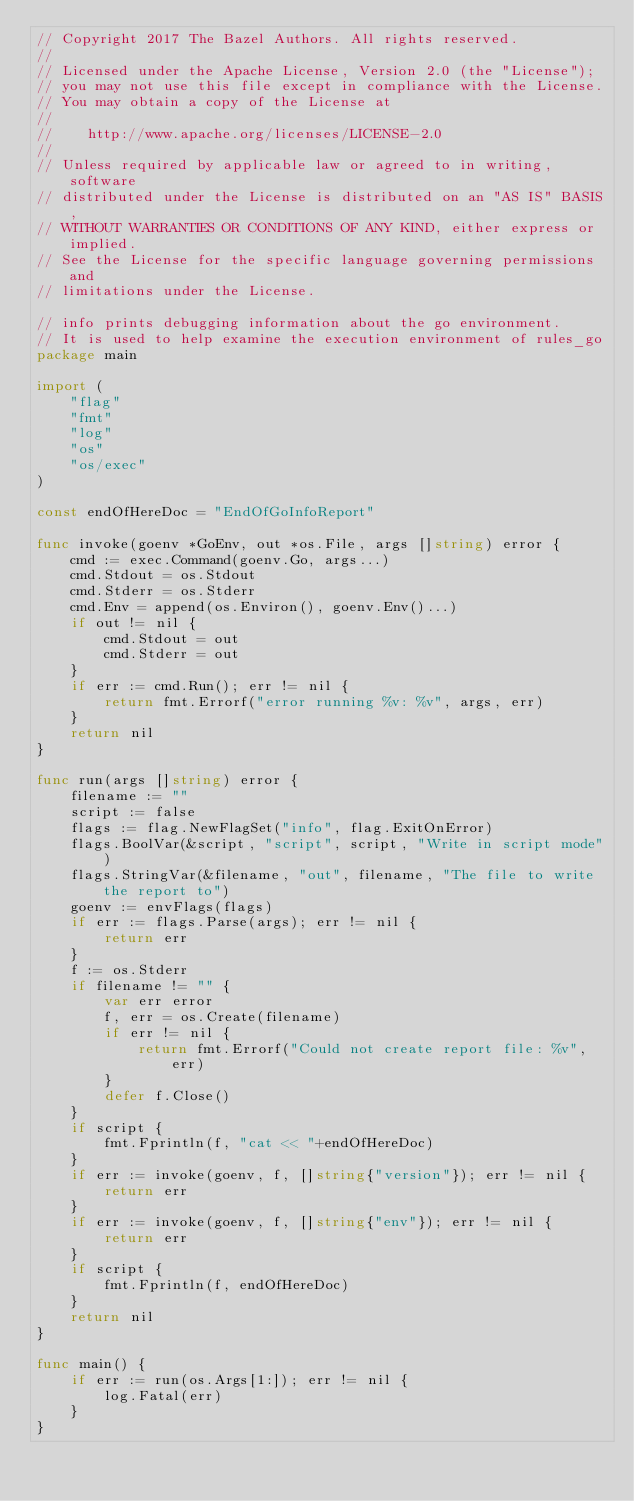Convert code to text. <code><loc_0><loc_0><loc_500><loc_500><_Go_>// Copyright 2017 The Bazel Authors. All rights reserved.
//
// Licensed under the Apache License, Version 2.0 (the "License");
// you may not use this file except in compliance with the License.
// You may obtain a copy of the License at
//
//    http://www.apache.org/licenses/LICENSE-2.0
//
// Unless required by applicable law or agreed to in writing, software
// distributed under the License is distributed on an "AS IS" BASIS,
// WITHOUT WARRANTIES OR CONDITIONS OF ANY KIND, either express or implied.
// See the License for the specific language governing permissions and
// limitations under the License.

// info prints debugging information about the go environment.
// It is used to help examine the execution environment of rules_go
package main

import (
	"flag"
	"fmt"
	"log"
	"os"
	"os/exec"
)

const endOfHereDoc = "EndOfGoInfoReport"

func invoke(goenv *GoEnv, out *os.File, args []string) error {
	cmd := exec.Command(goenv.Go, args...)
	cmd.Stdout = os.Stdout
	cmd.Stderr = os.Stderr
	cmd.Env = append(os.Environ(), goenv.Env()...)
	if out != nil {
		cmd.Stdout = out
		cmd.Stderr = out
	}
	if err := cmd.Run(); err != nil {
		return fmt.Errorf("error running %v: %v", args, err)
	}
	return nil
}

func run(args []string) error {
	filename := ""
	script := false
	flags := flag.NewFlagSet("info", flag.ExitOnError)
	flags.BoolVar(&script, "script", script, "Write in script mode")
	flags.StringVar(&filename, "out", filename, "The file to write the report to")
	goenv := envFlags(flags)
	if err := flags.Parse(args); err != nil {
		return err
	}
	f := os.Stderr
	if filename != "" {
		var err error
		f, err = os.Create(filename)
		if err != nil {
			return fmt.Errorf("Could not create report file: %v", err)
		}
		defer f.Close()
	}
	if script {
		fmt.Fprintln(f, "cat << "+endOfHereDoc)
	}
	if err := invoke(goenv, f, []string{"version"}); err != nil {
		return err
	}
	if err := invoke(goenv, f, []string{"env"}); err != nil {
		return err
	}
	if script {
		fmt.Fprintln(f, endOfHereDoc)
	}
	return nil
}

func main() {
	if err := run(os.Args[1:]); err != nil {
		log.Fatal(err)
	}
}
</code> 